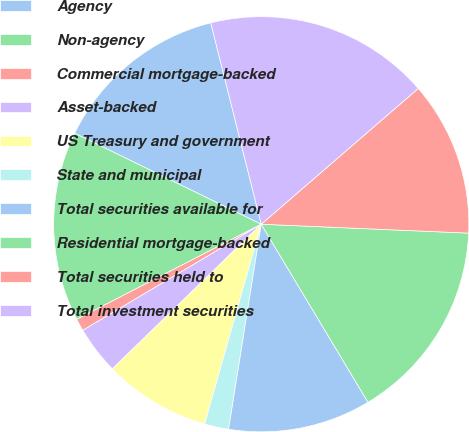Convert chart to OTSL. <chart><loc_0><loc_0><loc_500><loc_500><pie_chart><fcel>Agency<fcel>Non-agency<fcel>Commercial mortgage-backed<fcel>Asset-backed<fcel>US Treasury and government<fcel>State and municipal<fcel>Total securities available for<fcel>Residential mortgage-backed<fcel>Total securities held to<fcel>Total investment securities<nl><fcel>13.87%<fcel>14.8%<fcel>0.96%<fcel>3.73%<fcel>8.34%<fcel>1.88%<fcel>11.11%<fcel>15.72%<fcel>12.03%<fcel>17.56%<nl></chart> 